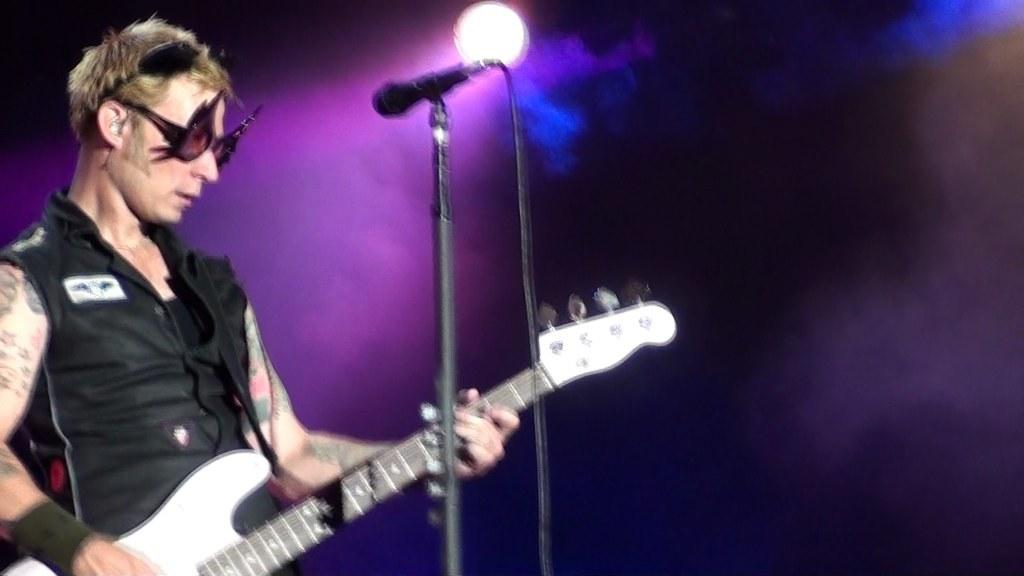What is the man in the image doing? The man is playing a guitar. What object is the man positioned in front of? The man is in front of a microphone. Can you describe the lighting in the image? There is a light above the man. How many lizards can be seen crawling on the ground in the image? There are no lizards present in the image. What type of town is visible in the background of the image? There is no town visible in the image; it only features a man playing a guitar, a microphone, and a light. 